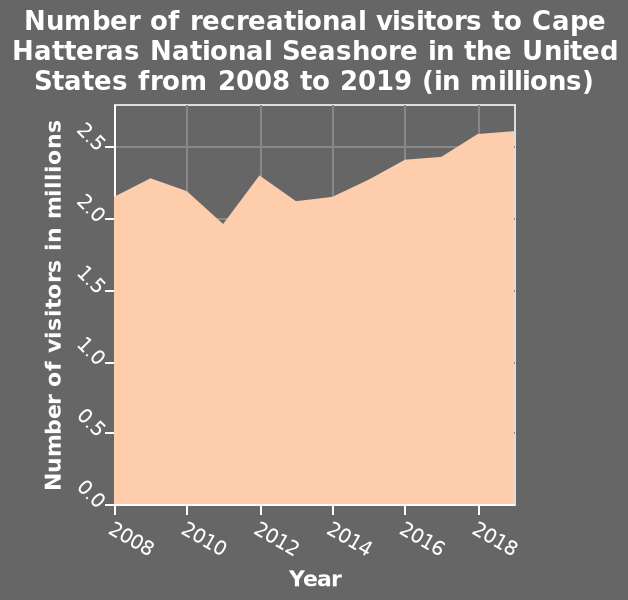<image>
What was the visitor count in the year when it fell below 2 million?  The visitor count fell below 2 million only in 2011. Has there been an overall increase in the number of visitors since 2013?  Yes, there has been an overall increase in the number of visitors since 2013. Which location does the plot represent? The plot represents the recreational visitors to Cape Hatteras National Seashore in the United States. 